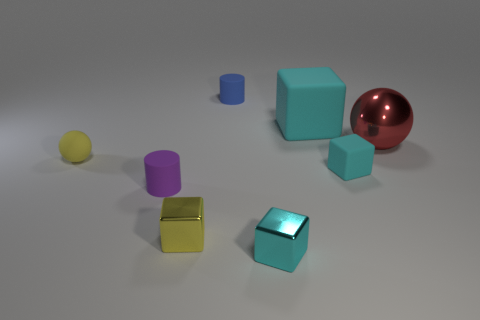There is a rubber thing that is the same color as the tiny rubber cube; what is its shape? cube 